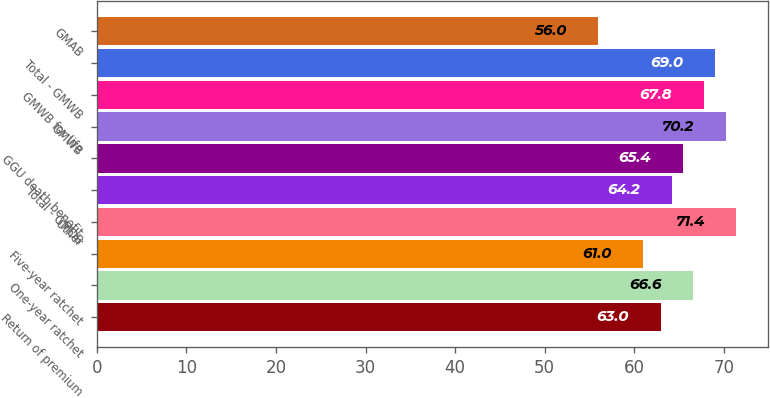Convert chart. <chart><loc_0><loc_0><loc_500><loc_500><bar_chart><fcel>Return of premium<fcel>One-year ratchet<fcel>Five-year ratchet<fcel>Other<fcel>Total - GMDB<fcel>GGU death benefit<fcel>GMWB<fcel>GMWB for life<fcel>Total - GMWB<fcel>GMAB<nl><fcel>63<fcel>66.6<fcel>61<fcel>71.4<fcel>64.2<fcel>65.4<fcel>70.2<fcel>67.8<fcel>69<fcel>56<nl></chart> 